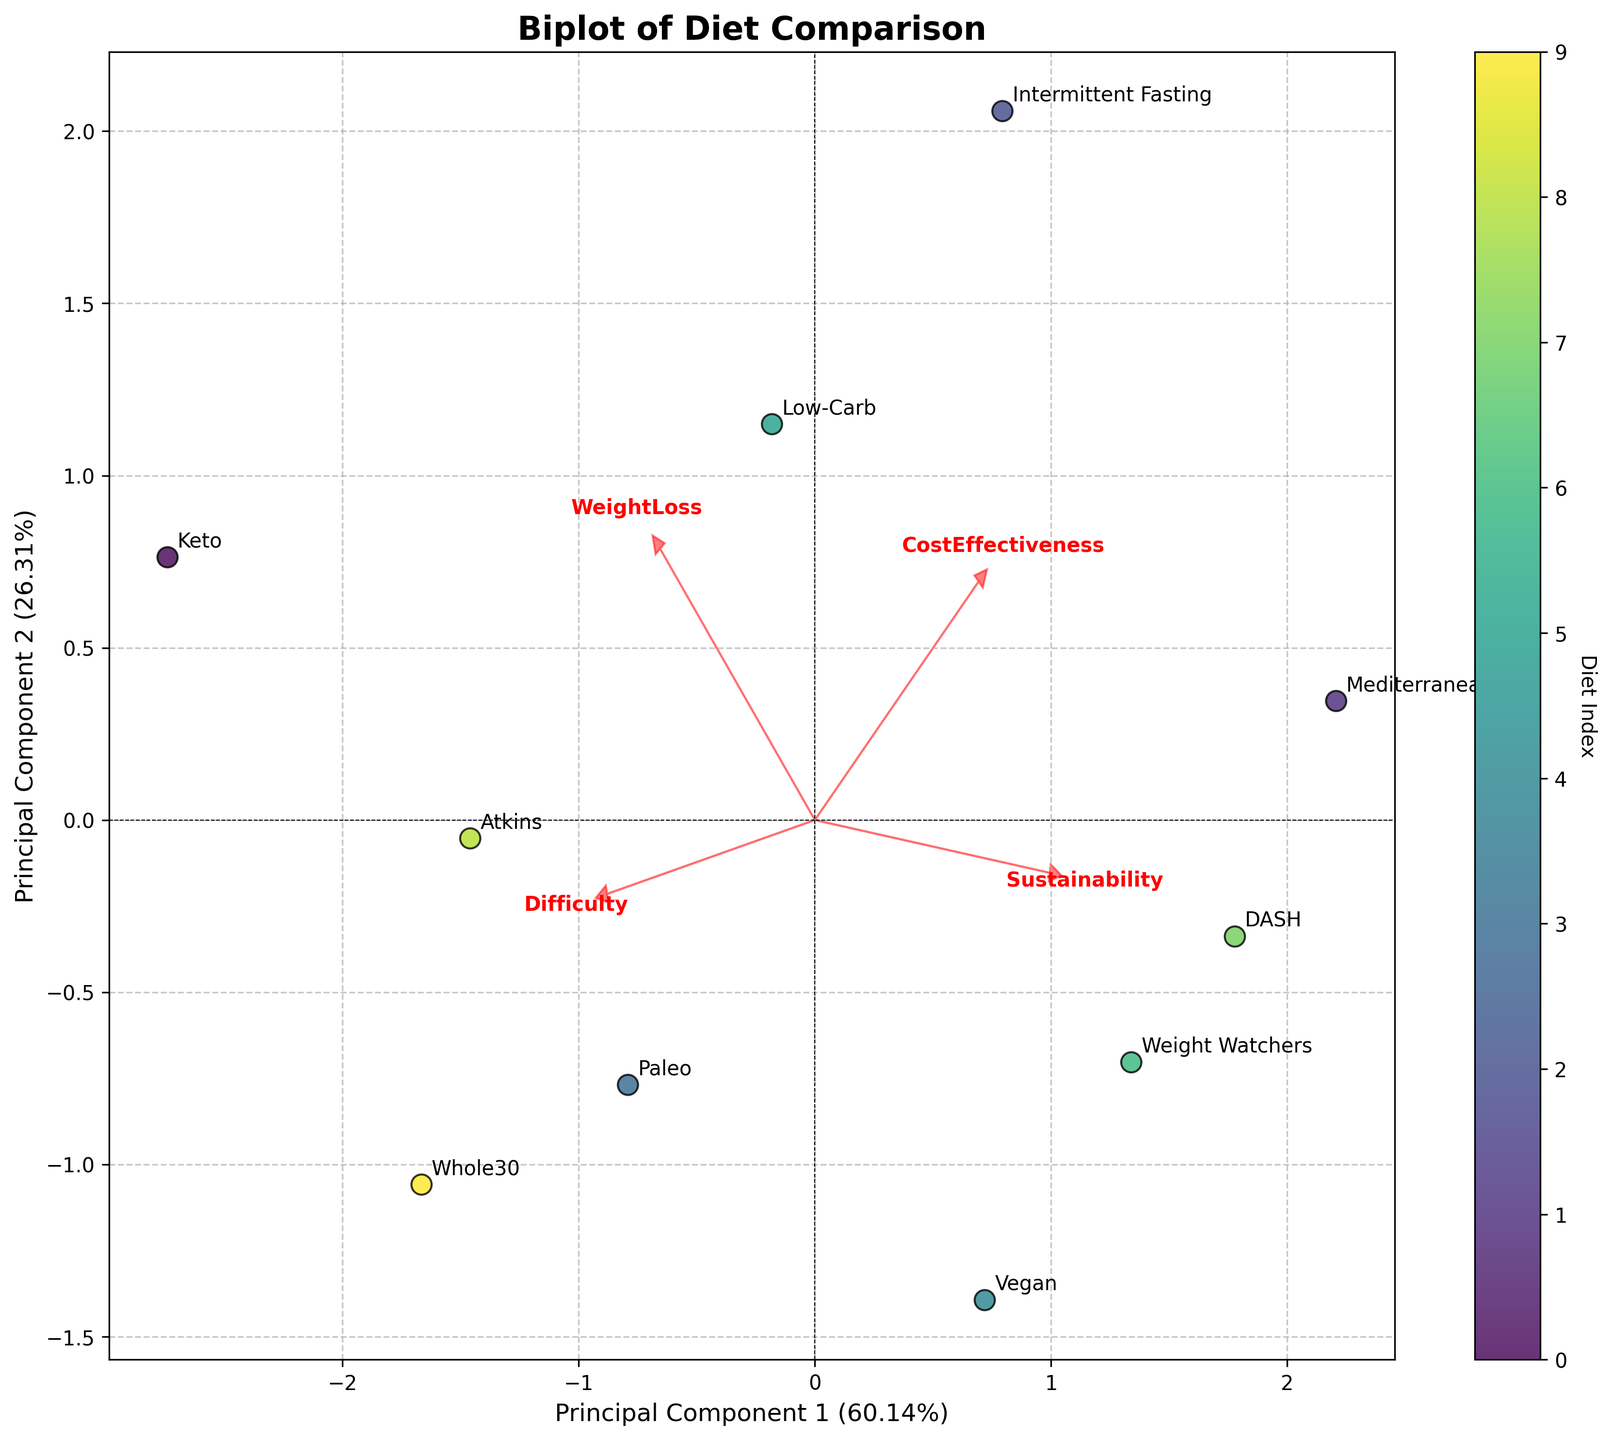What's the title of the plot? The title is located at the top of the plot and is usually prominent to describe the figure's content. In this case, it reads "Biplot of Diet Comparison".
Answer: Biplot of Diet Comparison How many diets are compared in the biplot? Each diet has a unique label plotted on the figure. Count the number of distinct labels to find this number. There are 10 unique diet labels.
Answer: 10 Which diet appears to rank highest on the first principal component (PC1)? Look at the axis labeled as Principal Component 1 (PC1) to see which diet has the highest value along this axis. 'Keto' is plotted furthest to the right on this axis.
Answer: Keto Which diet has the highest sustainability score according to the loadings? The sustainability score is represented by one of the red arrows. Find the arrow labeled "Sustainability" and see which direction it points toward. The 'Mediterranean' diet is closest to the end of the sustainability arrow.
Answer: Mediterranean How do "Weight Watchers" and "Whole30" compare in terms of PC1 and PC2 scores? Locate the positions of "Weight Watchers" and "Whole30" on the plot. "Weight Watchers" is to the left and lower than "Whole30" in terms of both PC1 and PC2 scores.
Answer: Whole30 scores higher on both PC1 and PC2 than Weight Watchers Which component explains more variance in the data according to the axis labels? Each axis label indicates the percentage of variance explained by that component. PC1 typically has a label indicating it explains more variance if its percentage is higher. In the plot, PC1 has a higher percentage than PC2.
Answer: PC1 What are the directions of the 'WeightLoss' and 'CostEffectiveness' arrows, and what does it imply for diets in those directions? The arrows represent the directionality of these features. 'WeightLoss' points toward the right and slightly downward; 'CostEffectiveness' points more upward and to the left. Diets in these directions are aligned with these characteristics; for instance, 'Keto' aligns with higher weight loss while 'Intermittent Fasting' aligns with better cost-effectiveness.
Answer: Weight loss: right and slight down; Cost effectiveness: up and left Which diet appears to be notably more difficult according to the loadings? The difficulty of a diet is shown by the position in the biplot relative to the 'Difficulty' loading arrow. 'Whole30' appears closest to the head of the 'Difficulty' arrow.
Answer: Whole30 How do PC1 and PC2 jointly explain the overall variance in the dataset based on their percentages? Sum the percentages of variance each principal component explains to get the total. The axis label indicates PC1 covers 45% and PC2 covers 30%. Together, they explain 75% of the variance.
Answer: 75% What can we infer about the 'Vegan' diet based on its position relative to the 'Sustainability' and 'Difficulty' arrows? The 'Vegan' diet is located near the arrows for 'Sustainability' and 'Difficulty,' indicating it has high sustainability and moderate difficulty.
Answer: High sustainability and moderate difficulty 